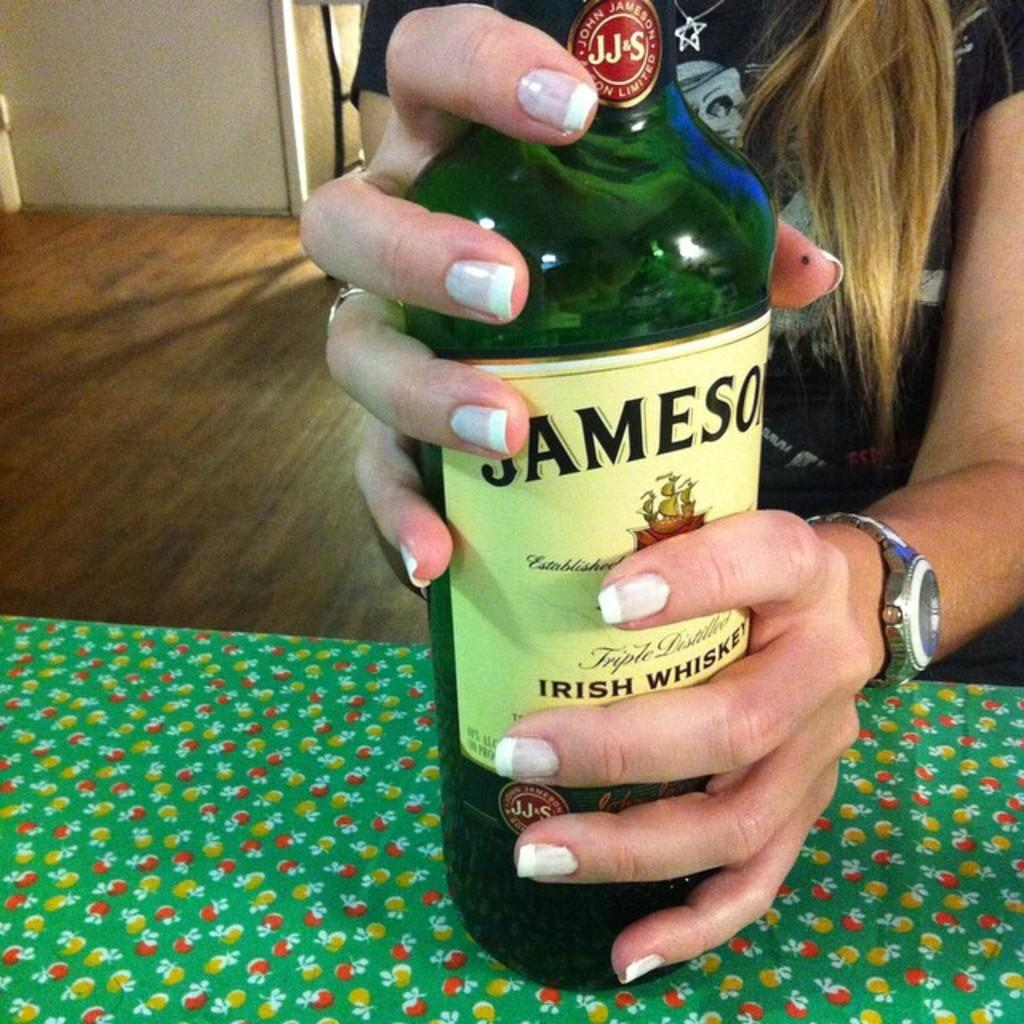What is the main subject of the image? There is a person in the image. What is the person holding in the image? The person is holding a bottle. What type of surface is visible in the image? There is a floor visible in the image. What architectural feature can be seen in the image? There is a wall in the image. What is the horse doing in the image? There is no horse present in the image. How does the person's mind move in the image? The person's mind is not visible in the image, so it cannot be determined how it moves. 